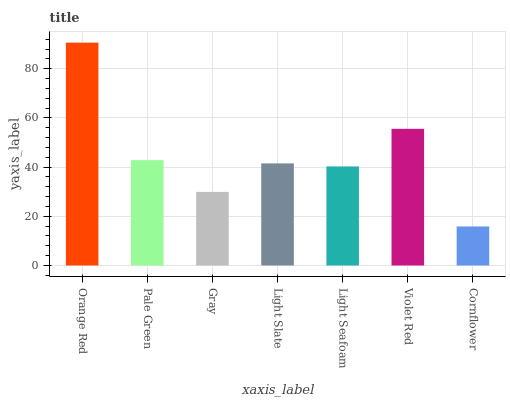Is Pale Green the minimum?
Answer yes or no. No. Is Pale Green the maximum?
Answer yes or no. No. Is Orange Red greater than Pale Green?
Answer yes or no. Yes. Is Pale Green less than Orange Red?
Answer yes or no. Yes. Is Pale Green greater than Orange Red?
Answer yes or no. No. Is Orange Red less than Pale Green?
Answer yes or no. No. Is Light Slate the high median?
Answer yes or no. Yes. Is Light Slate the low median?
Answer yes or no. Yes. Is Light Seafoam the high median?
Answer yes or no. No. Is Gray the low median?
Answer yes or no. No. 